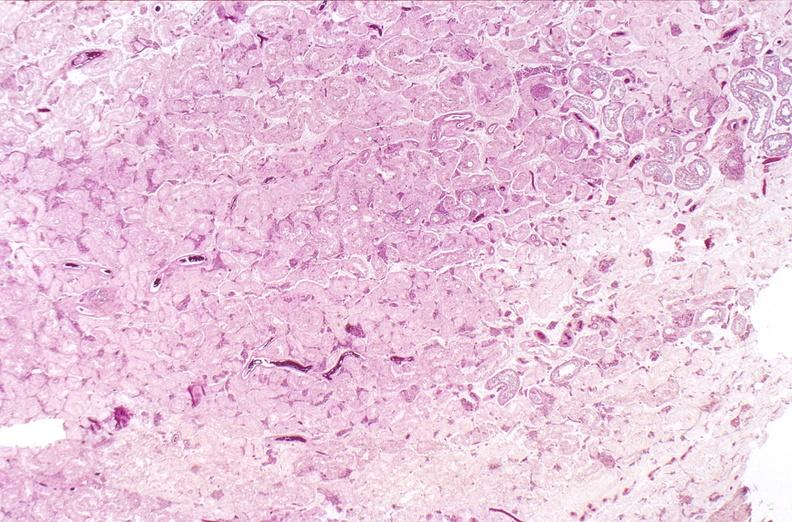what does this image show?
Answer the question using a single word or phrase. Testes 